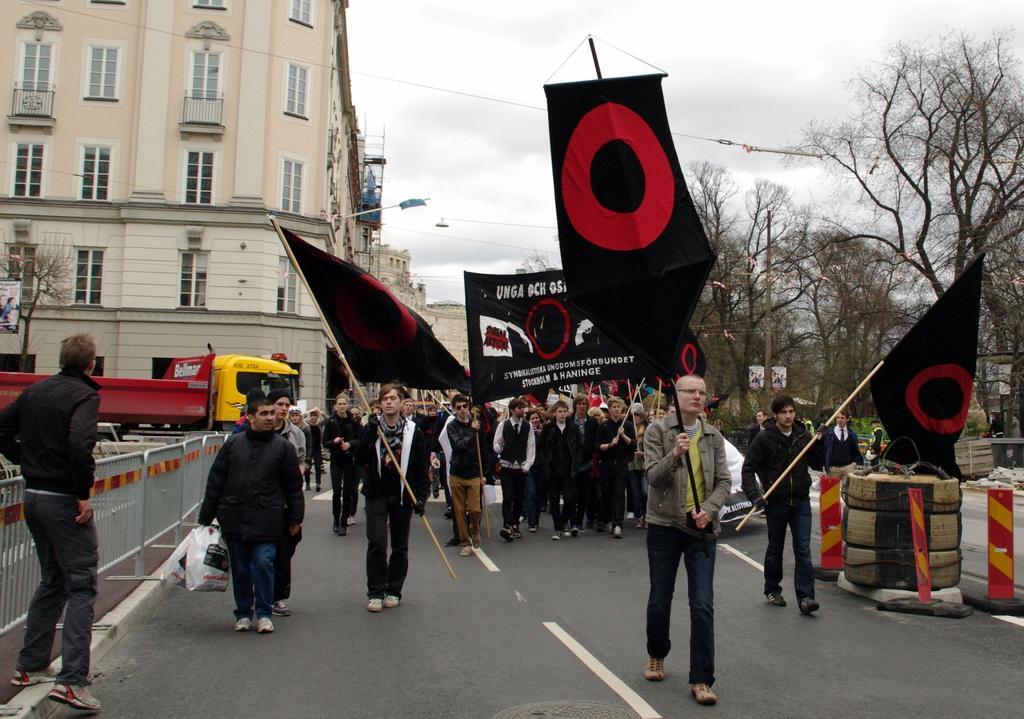Can you describe this image briefly? This image is taken outdoors. At the top of the image there is the sky with clouds. In the background there are a few buildings. A truck is moving on the road. There are a few trees and there are a few boards. On the left side of the image there is a railing. On the right side of the image there are two safety cones and there are a few things on the road. In the middle of the image many people are walking on the road and a few are holding flags and banners with text on them. 